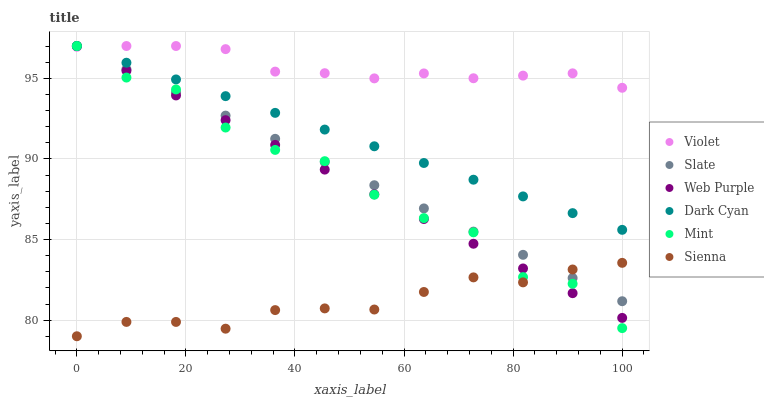Does Sienna have the minimum area under the curve?
Answer yes or no. Yes. Does Violet have the maximum area under the curve?
Answer yes or no. Yes. Does Web Purple have the minimum area under the curve?
Answer yes or no. No. Does Web Purple have the maximum area under the curve?
Answer yes or no. No. Is Web Purple the smoothest?
Answer yes or no. Yes. Is Mint the roughest?
Answer yes or no. Yes. Is Sienna the smoothest?
Answer yes or no. No. Is Sienna the roughest?
Answer yes or no. No. Does Sienna have the lowest value?
Answer yes or no. Yes. Does Web Purple have the lowest value?
Answer yes or no. No. Does Mint have the highest value?
Answer yes or no. Yes. Does Sienna have the highest value?
Answer yes or no. No. Is Sienna less than Dark Cyan?
Answer yes or no. Yes. Is Violet greater than Sienna?
Answer yes or no. Yes. Does Violet intersect Dark Cyan?
Answer yes or no. Yes. Is Violet less than Dark Cyan?
Answer yes or no. No. Is Violet greater than Dark Cyan?
Answer yes or no. No. Does Sienna intersect Dark Cyan?
Answer yes or no. No. 